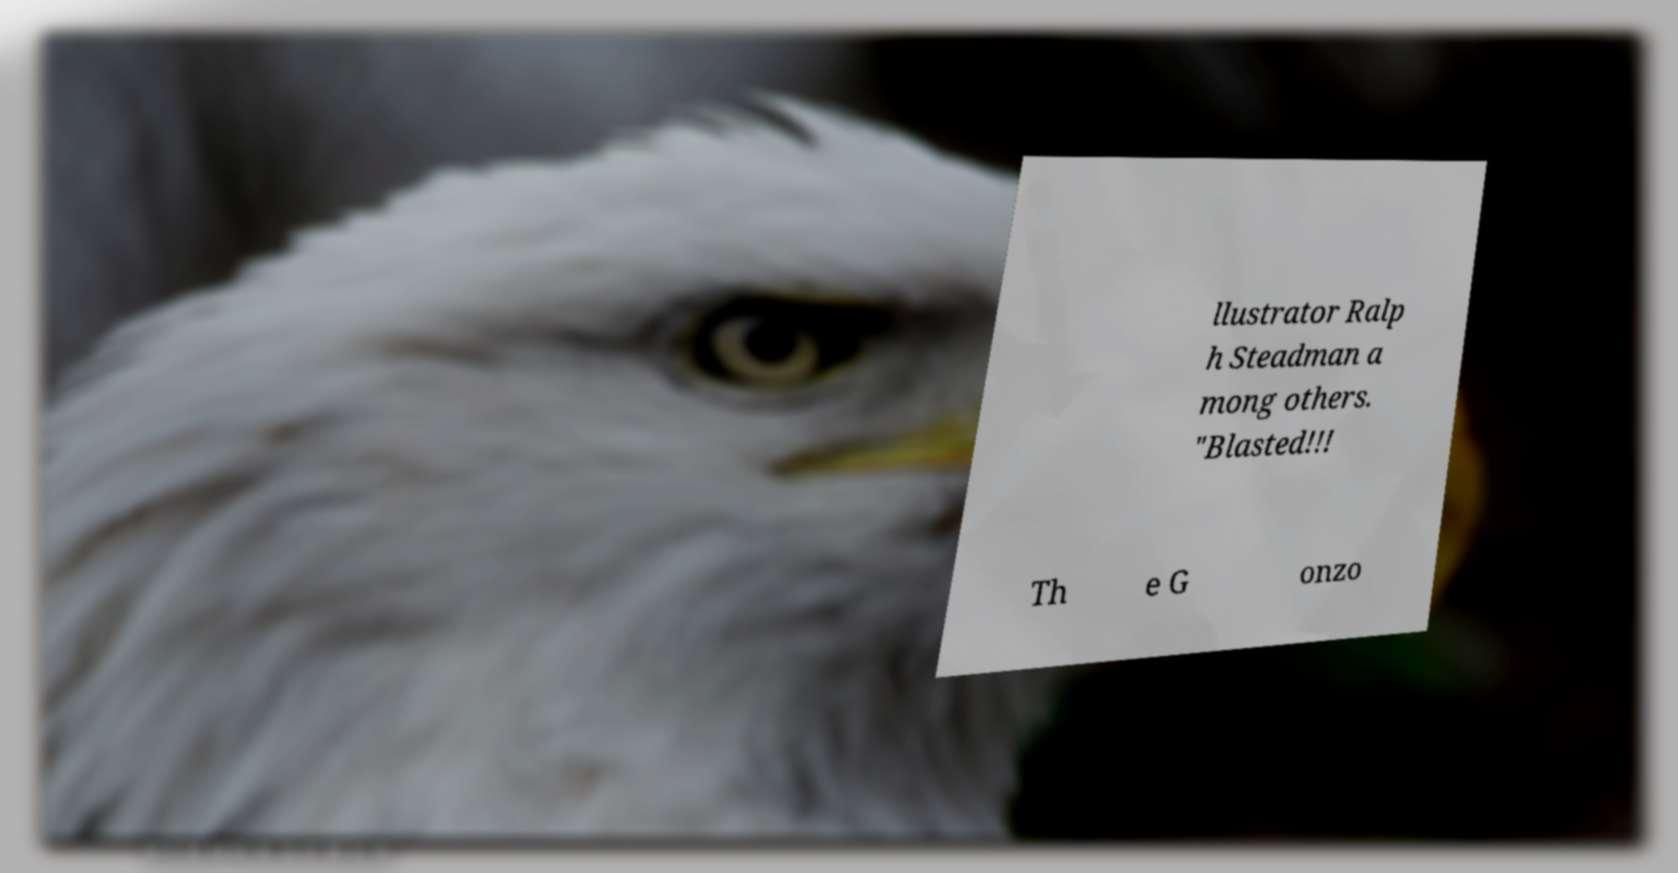Please read and relay the text visible in this image. What does it say? llustrator Ralp h Steadman a mong others. "Blasted!!! Th e G onzo 